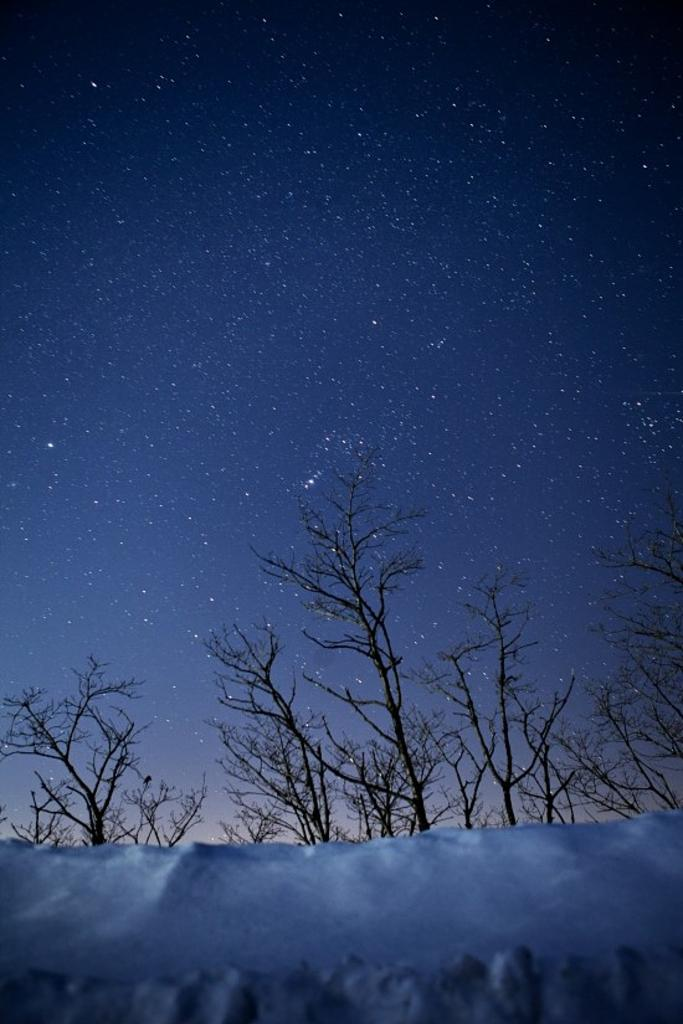What type of weather is depicted in the image? The image shows snow at the bottom, indicating cold weather. What can be seen in the middle of the image? There are trees in the middle of the image. What is visible at the top of the image? The sky is visible at the top of the image. How many family members are visible in the image? There are no family members present in the image; it only shows snow, trees, and the sky. What type of clouds can be seen in the image? There is no mention of clouds in the image; it only shows snow, trees, and the sky. 